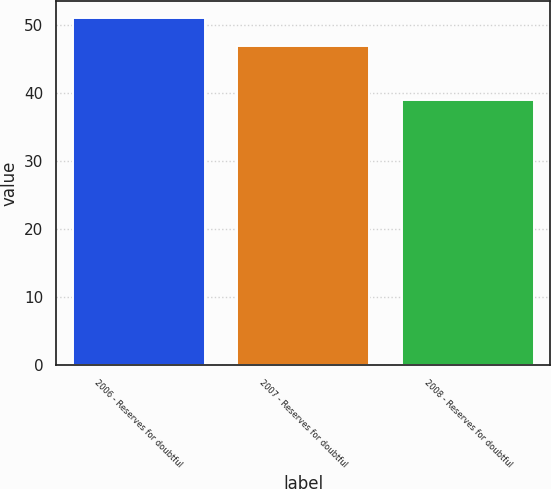Convert chart. <chart><loc_0><loc_0><loc_500><loc_500><bar_chart><fcel>2006 - Reserves for doubtful<fcel>2007 - Reserves for doubtful<fcel>2008 - Reserves for doubtful<nl><fcel>51<fcel>47<fcel>39<nl></chart> 